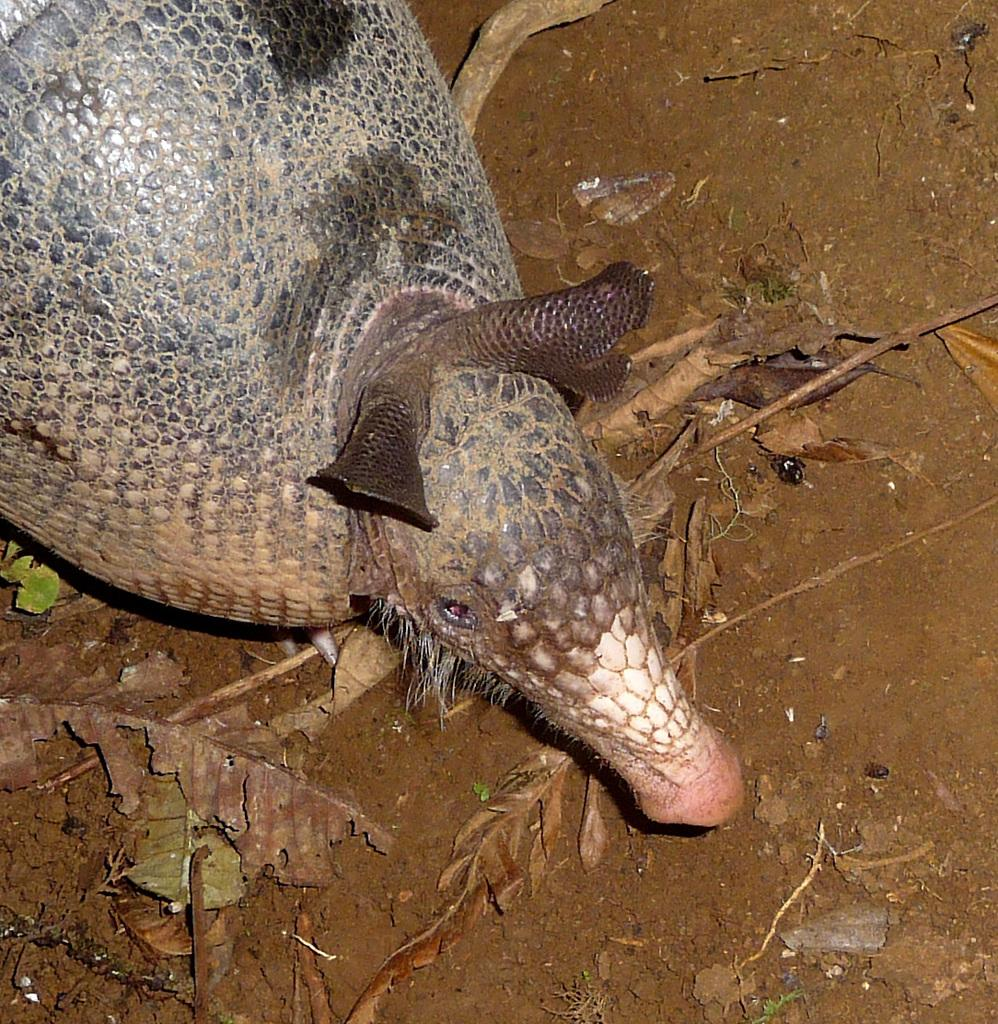What type of creature is in the image? There is an animal in the image. Where is the animal located? The animal is on the ground. What else can be seen in the image besides the animal? There are dried leaves in the image. What type of beef is being served at the church in the image? There is no church or beef present in the image; it features an animal on the ground and dried leaves. 